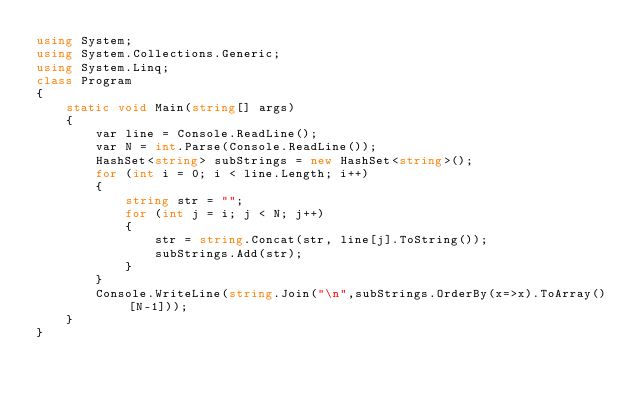<code> <loc_0><loc_0><loc_500><loc_500><_C#_>using System;
using System.Collections.Generic;
using System.Linq;
class Program
{
    static void Main(string[] args)
    {
        var line = Console.ReadLine();
        var N = int.Parse(Console.ReadLine());
        HashSet<string> subStrings = new HashSet<string>();
        for (int i = 0; i < line.Length; i++)
        {
            string str = "";
            for (int j = i; j < N; j++)
            {
                str = string.Concat(str, line[j].ToString());
                subStrings.Add(str);
            }
        }
        Console.WriteLine(string.Join("\n",subStrings.OrderBy(x=>x).ToArray()[N-1]));
    }
}</code> 